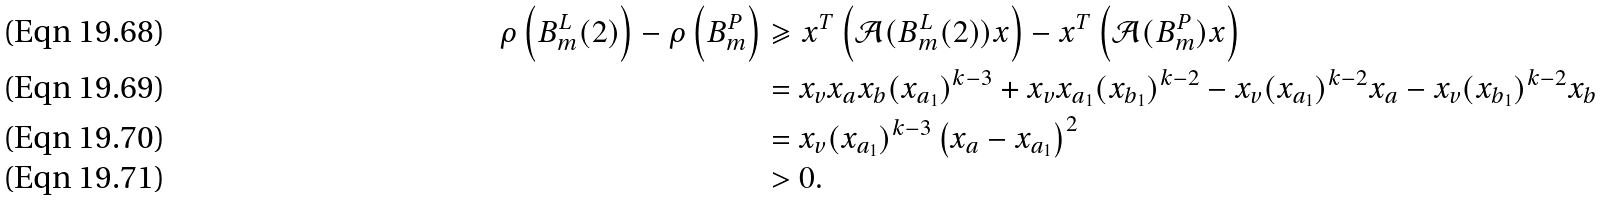<formula> <loc_0><loc_0><loc_500><loc_500>\rho \left ( B _ { m } ^ { L } ( 2 ) \right ) - \rho \left ( B _ { m } ^ { P } \right ) & \geqslant x ^ { T } \left ( \mathcal { A } ( B _ { m } ^ { L } ( 2 ) ) x \right ) - x ^ { T } \left ( \mathcal { A } ( B _ { m } ^ { P } ) x \right ) \\ & = x _ { v } x _ { a } x _ { b } ( x _ { a _ { 1 } } ) ^ { k - 3 } + x _ { v } x _ { a _ { 1 } } ( x _ { b _ { 1 } } ) ^ { k - 2 } - x _ { v } ( x _ { a _ { 1 } } ) ^ { k - 2 } x _ { a } - x _ { v } ( x _ { b _ { 1 } } ) ^ { k - 2 } x _ { b } \\ & = x _ { v } ( x _ { a _ { 1 } } ) ^ { k - 3 } \left ( x _ { a } - x _ { a _ { 1 } } \right ) ^ { 2 } \\ & > 0 .</formula> 